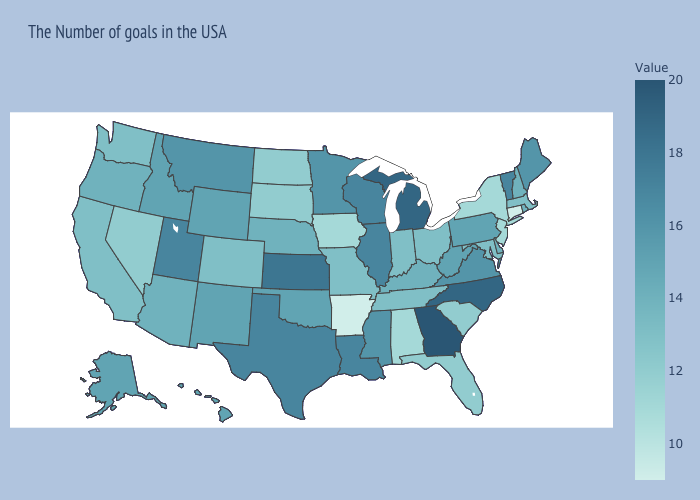Does New Mexico have the highest value in the West?
Answer briefly. No. Among the states that border New Jersey , does New York have the lowest value?
Quick response, please. Yes. Does the map have missing data?
Be succinct. No. Which states have the highest value in the USA?
Quick response, please. Georgia. Among the states that border Wisconsin , which have the lowest value?
Short answer required. Iowa. Does the map have missing data?
Answer briefly. No. Among the states that border South Carolina , does North Carolina have the lowest value?
Answer briefly. Yes. Does New York have a lower value than Arkansas?
Answer briefly. No. Does Nebraska have a lower value than Wisconsin?
Write a very short answer. Yes. 